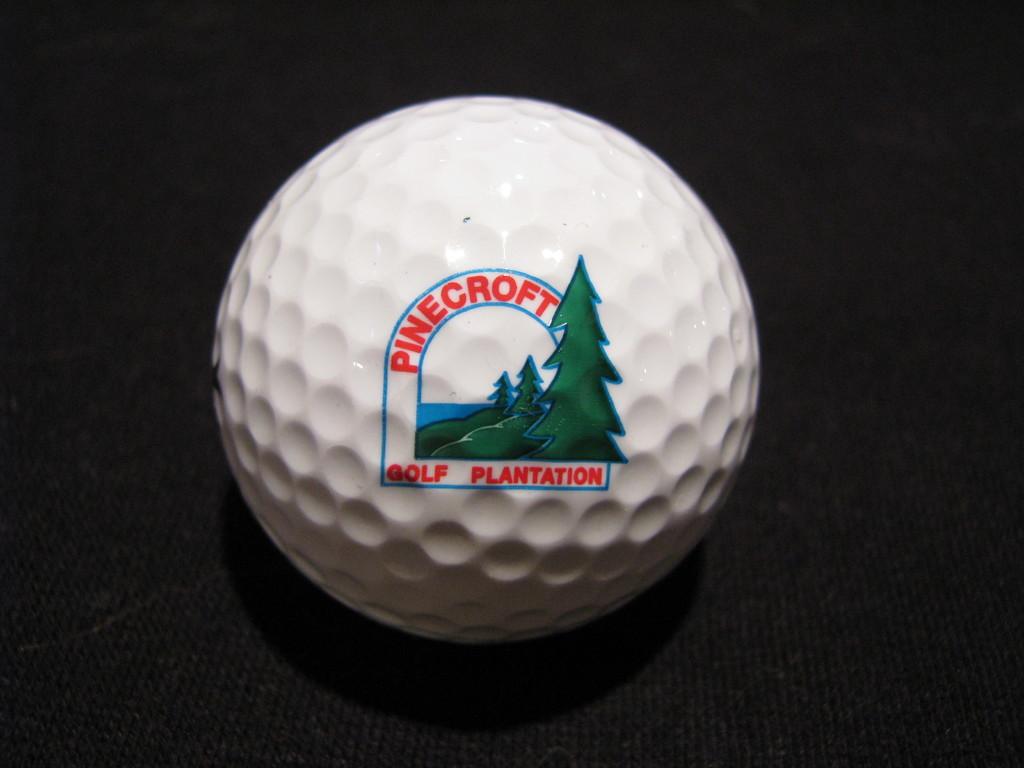Where is this gold plantation located?
Provide a succinct answer. Pinecroft. What is pinecroft?
Make the answer very short. Golf plantation. 